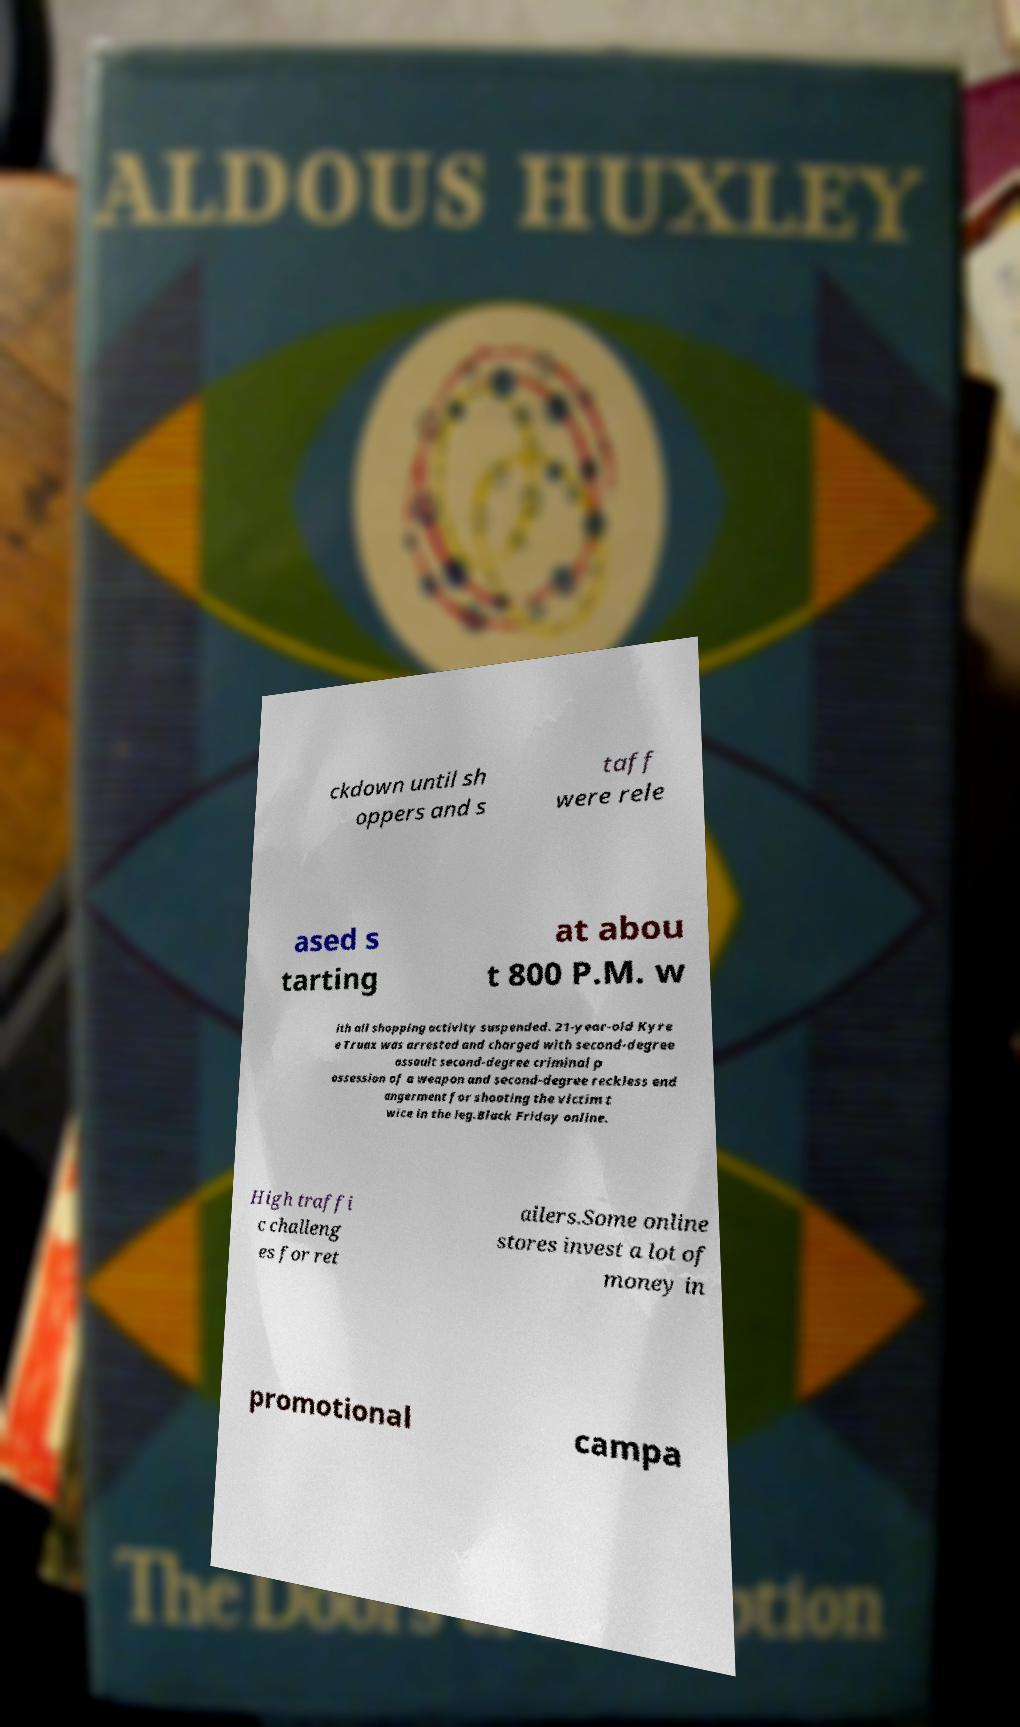Please identify and transcribe the text found in this image. ckdown until sh oppers and s taff were rele ased s tarting at abou t 800 P.M. w ith all shopping activity suspended. 21-year-old Kyre e Truax was arrested and charged with second-degree assault second-degree criminal p ossession of a weapon and second-degree reckless end angerment for shooting the victim t wice in the leg.Black Friday online. High traffi c challeng es for ret ailers.Some online stores invest a lot of money in promotional campa 